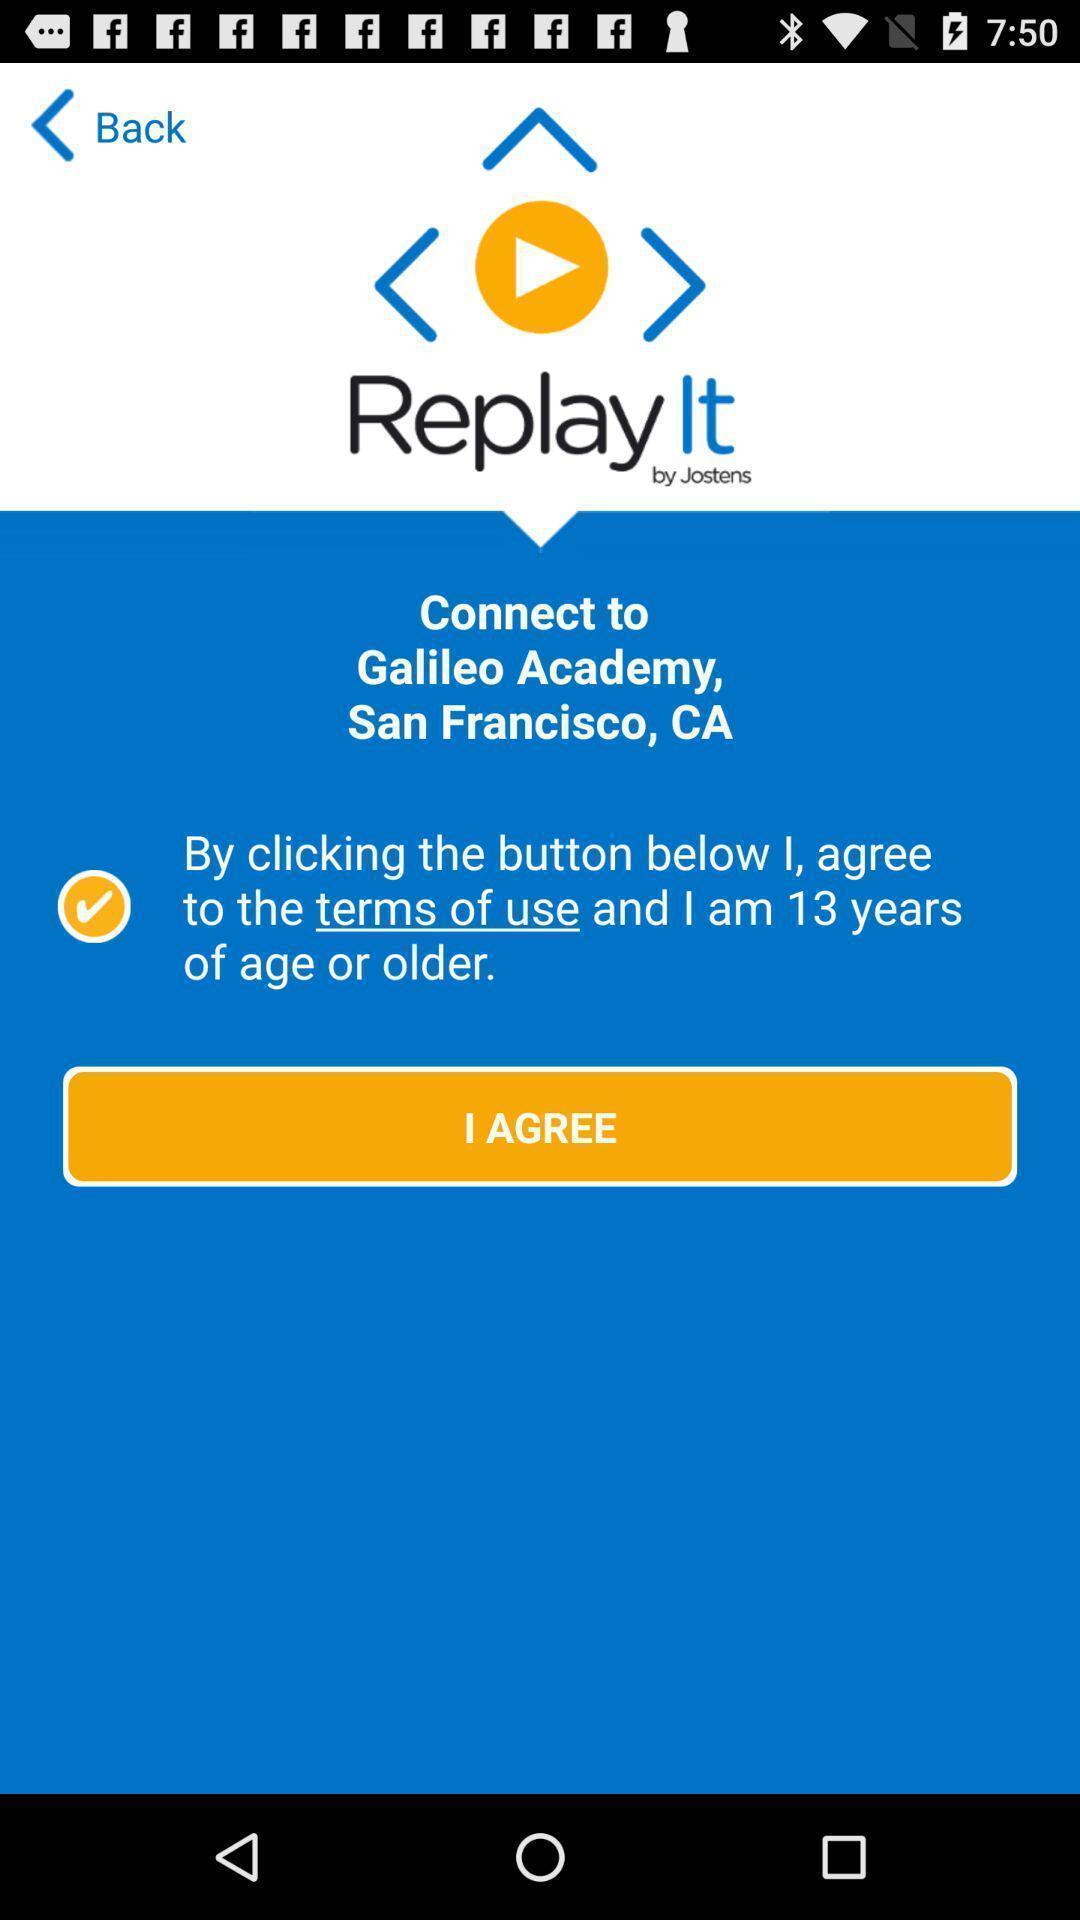Summarize the information in this screenshot. Page to agree terms in application. 